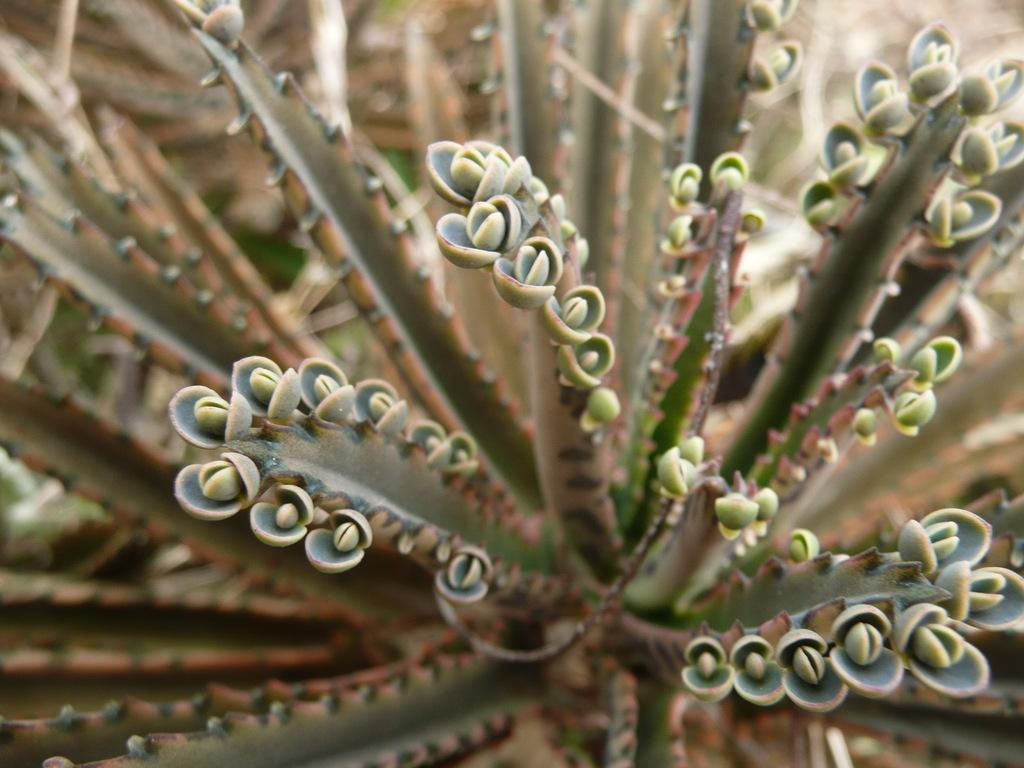What is the main subject of the image? The main subject of the image is a plant. Where is the plant located in the image? The plant is in the center of the image. What is the current stage of the plant's growth? The plant has buds, indicating that it is in the process of blooming. What type of pencil does the uncle use to draw the plant in the image? There is no uncle or pencil present in the image, as it only features a plant with buds. 